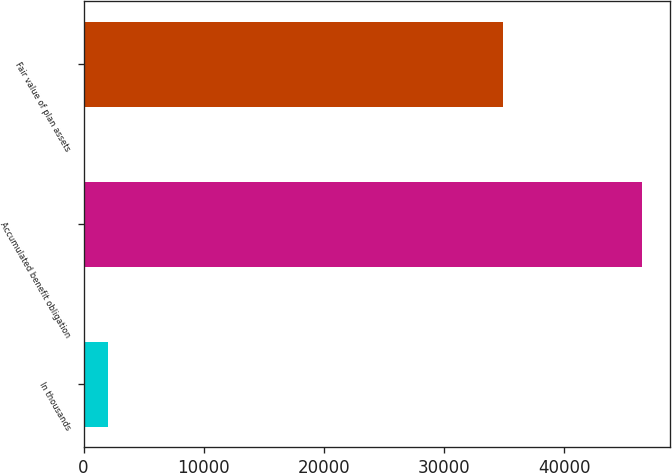Convert chart. <chart><loc_0><loc_0><loc_500><loc_500><bar_chart><fcel>In thousands<fcel>Accumulated benefit obligation<fcel>Fair value of plan assets<nl><fcel>2009<fcel>46472<fcel>34872<nl></chart> 